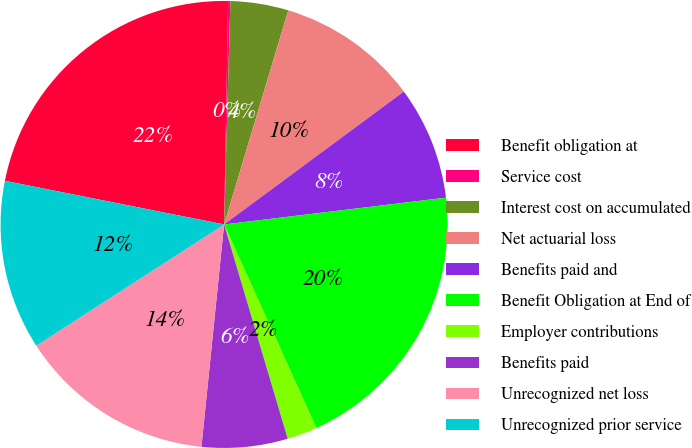Convert chart to OTSL. <chart><loc_0><loc_0><loc_500><loc_500><pie_chart><fcel>Benefit obligation at<fcel>Service cost<fcel>Interest cost on accumulated<fcel>Net actuarial loss<fcel>Benefits paid and<fcel>Benefit Obligation at End of<fcel>Employer contributions<fcel>Benefits paid<fcel>Unrecognized net loss<fcel>Unrecognized prior service<nl><fcel>22.16%<fcel>0.16%<fcel>4.19%<fcel>10.23%<fcel>8.22%<fcel>20.14%<fcel>2.18%<fcel>6.21%<fcel>14.26%<fcel>12.25%<nl></chart> 